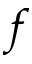Convert formula to latex. <formula><loc_0><loc_0><loc_500><loc_500>f</formula> 